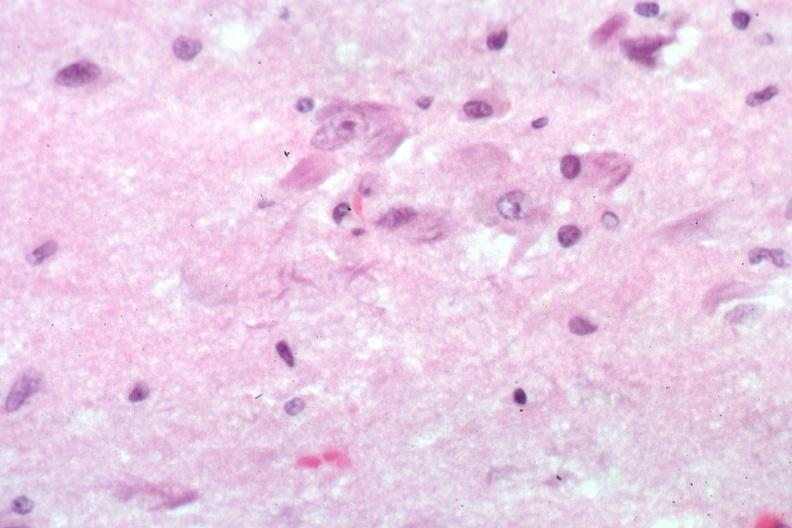s typical ivory vertebra present?
Answer the question using a single word or phrase. No 